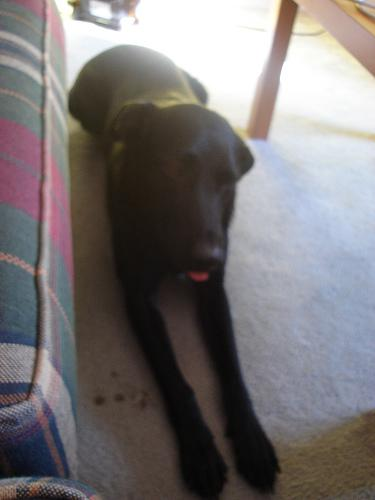Question: where is this picture taken?
Choices:
A. Kitchen.
B. Dining area.
C. Living room.
D. Basement.
Answer with the letter. Answer: C Question: what color is the carpet?
Choices:
A. Red.
B. Cream.
C. Blue.
D. Green.
Answer with the letter. Answer: B 